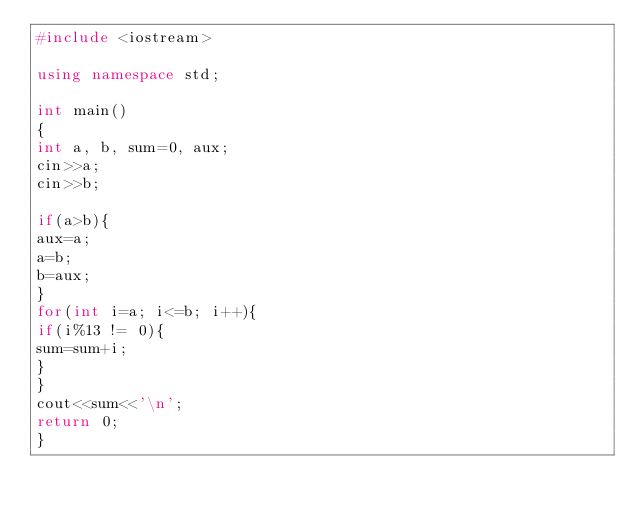Convert code to text. <code><loc_0><loc_0><loc_500><loc_500><_C++_>#include <iostream>

using namespace std;

int main()
{
int a, b, sum=0, aux;
cin>>a;
cin>>b;

if(a>b){
aux=a;
a=b;
b=aux;
}
for(int i=a; i<=b; i++){
if(i%13 != 0){
sum=sum+i;
}
}
cout<<sum<<'\n';
return 0;
}</code> 